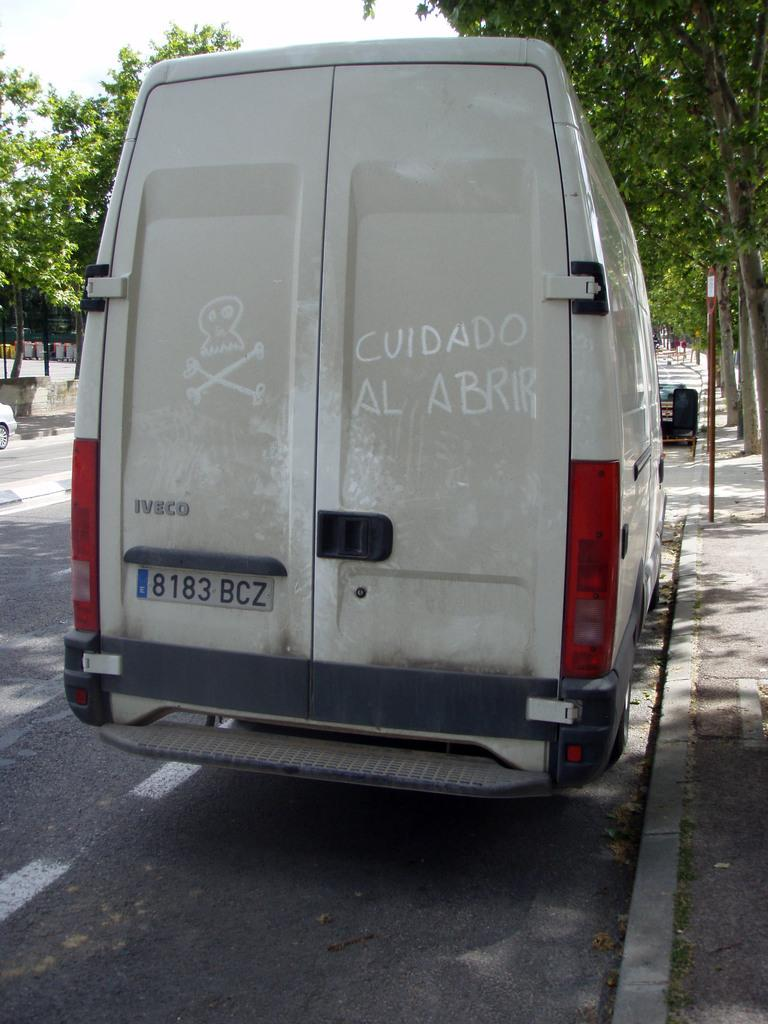What is on the road in the image? There is a vehicle on the road in the image. What structures can be seen in the image? There are poles and a wall visible in the image. What type of vegetation is present in the image? There are trees in the image. What can be seen in the background of the image? The sky is visible in the background of the image. What type of spark can be seen coming from the trees in the image? There is no spark visible in the image; the trees are not emitting any sparks. Is there any magic happening in the image? There is no indication of magic in the image; it depicts a vehicle on the road, poles, a wall, trees, and the sky. 